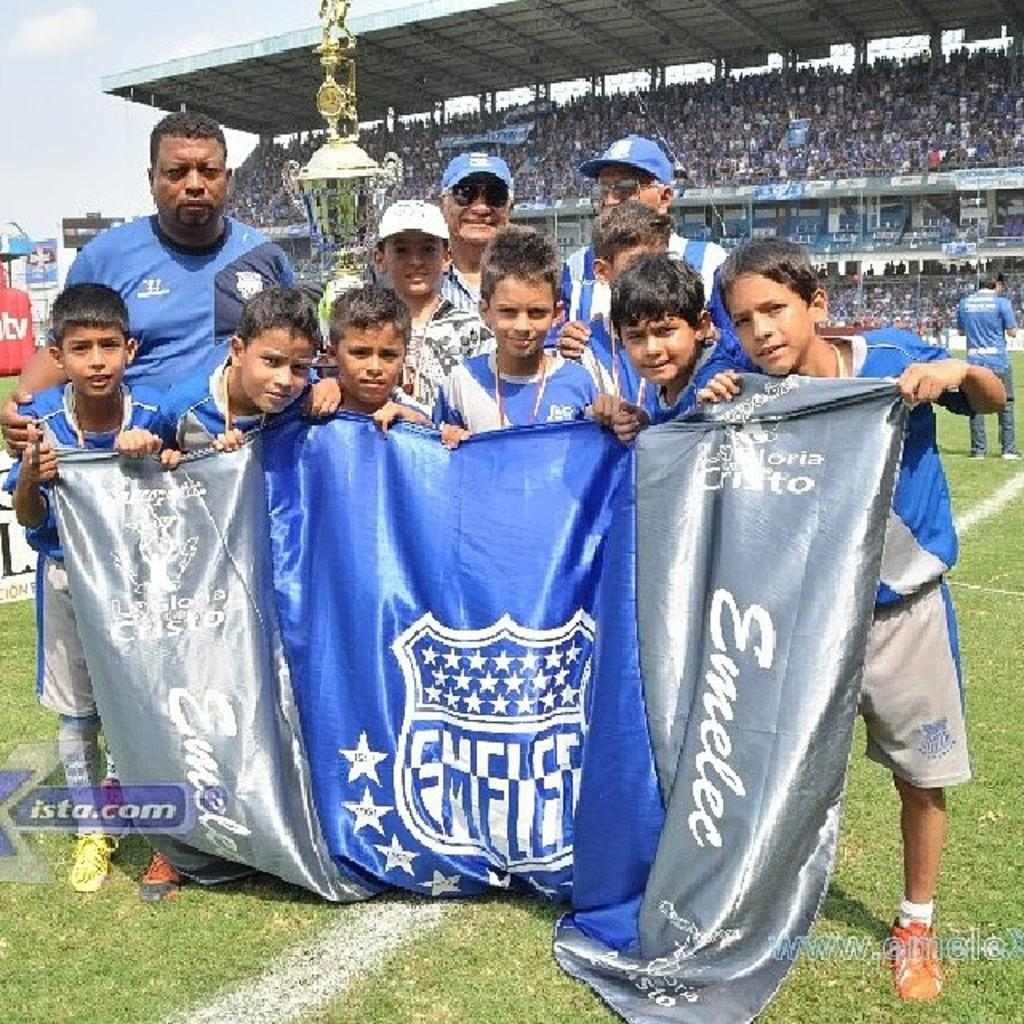<image>
Present a compact description of the photo's key features. a flag that has writing on it and an ista.com advertisement 